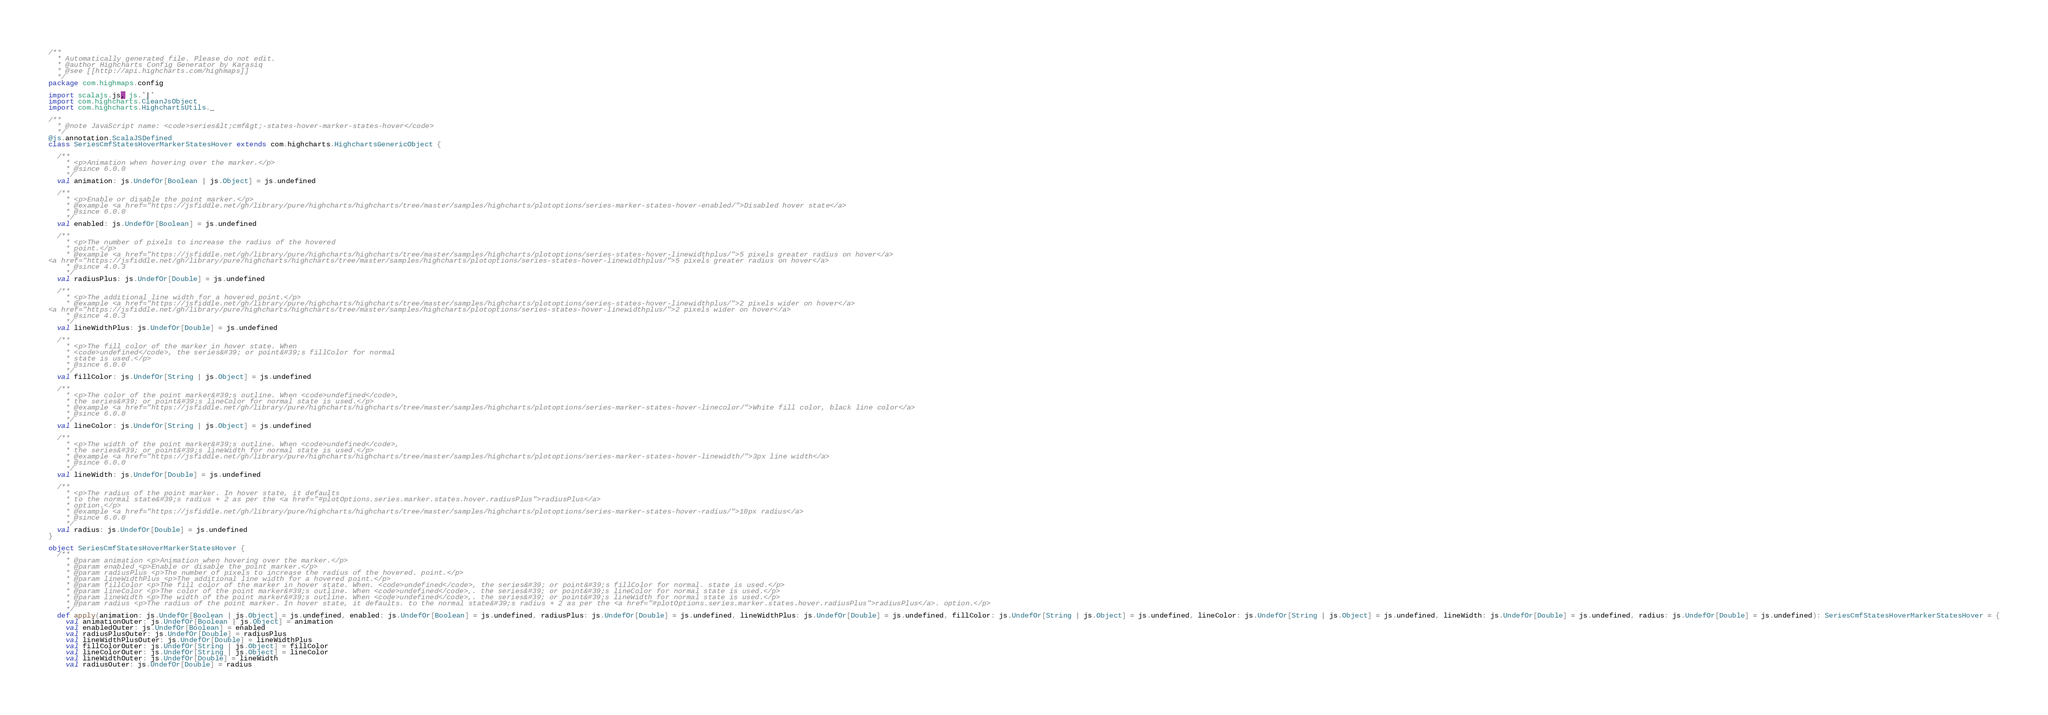<code> <loc_0><loc_0><loc_500><loc_500><_Scala_>/**
  * Automatically generated file. Please do not edit.
  * @author Highcharts Config Generator by Karasiq
  * @see [[http://api.highcharts.com/highmaps]]
  */
package com.highmaps.config

import scalajs.js, js.`|`
import com.highcharts.CleanJsObject
import com.highcharts.HighchartsUtils._

/**
  * @note JavaScript name: <code>series&lt;cmf&gt;-states-hover-marker-states-hover</code>
  */
@js.annotation.ScalaJSDefined
class SeriesCmfStatesHoverMarkerStatesHover extends com.highcharts.HighchartsGenericObject {

  /**
    * <p>Animation when hovering over the marker.</p>
    * @since 6.0.0
    */
  val animation: js.UndefOr[Boolean | js.Object] = js.undefined

  /**
    * <p>Enable or disable the point marker.</p>
    * @example <a href="https://jsfiddle.net/gh/library/pure/highcharts/highcharts/tree/master/samples/highcharts/plotoptions/series-marker-states-hover-enabled/">Disabled hover state</a>
    * @since 6.0.0
    */
  val enabled: js.UndefOr[Boolean] = js.undefined

  /**
    * <p>The number of pixels to increase the radius of the hovered
    * point.</p>
    * @example <a href="https://jsfiddle.net/gh/library/pure/highcharts/highcharts/tree/master/samples/highcharts/plotoptions/series-states-hover-linewidthplus/">5 pixels greater radius on hover</a>
<a href="https://jsfiddle.net/gh/library/pure/highcharts/highcharts/tree/master/samples/highcharts/plotoptions/series-states-hover-linewidthplus/">5 pixels greater radius on hover</a>
    * @since 4.0.3
    */
  val radiusPlus: js.UndefOr[Double] = js.undefined

  /**
    * <p>The additional line width for a hovered point.</p>
    * @example <a href="https://jsfiddle.net/gh/library/pure/highcharts/highcharts/tree/master/samples/highcharts/plotoptions/series-states-hover-linewidthplus/">2 pixels wider on hover</a>
<a href="https://jsfiddle.net/gh/library/pure/highcharts/highcharts/tree/master/samples/highcharts/plotoptions/series-states-hover-linewidthplus/">2 pixels wider on hover</a>
    * @since 4.0.3
    */
  val lineWidthPlus: js.UndefOr[Double] = js.undefined

  /**
    * <p>The fill color of the marker in hover state. When
    * <code>undefined</code>, the series&#39; or point&#39;s fillColor for normal
    * state is used.</p>
    * @since 6.0.0
    */
  val fillColor: js.UndefOr[String | js.Object] = js.undefined

  /**
    * <p>The color of the point marker&#39;s outline. When <code>undefined</code>,
    * the series&#39; or point&#39;s lineColor for normal state is used.</p>
    * @example <a href="https://jsfiddle.net/gh/library/pure/highcharts/highcharts/tree/master/samples/highcharts/plotoptions/series-marker-states-hover-linecolor/">White fill color, black line color</a>
    * @since 6.0.0
    */
  val lineColor: js.UndefOr[String | js.Object] = js.undefined

  /**
    * <p>The width of the point marker&#39;s outline. When <code>undefined</code>,
    * the series&#39; or point&#39;s lineWidth for normal state is used.</p>
    * @example <a href="https://jsfiddle.net/gh/library/pure/highcharts/highcharts/tree/master/samples/highcharts/plotoptions/series-marker-states-hover-linewidth/">3px line width</a>
    * @since 6.0.0
    */
  val lineWidth: js.UndefOr[Double] = js.undefined

  /**
    * <p>The radius of the point marker. In hover state, it defaults
    * to the normal state&#39;s radius + 2 as per the <a href="#plotOptions.series.marker.states.hover.radiusPlus">radiusPlus</a>
    * option.</p>
    * @example <a href="https://jsfiddle.net/gh/library/pure/highcharts/highcharts/tree/master/samples/highcharts/plotoptions/series-marker-states-hover-radius/">10px radius</a>
    * @since 6.0.0
    */
  val radius: js.UndefOr[Double] = js.undefined
}

object SeriesCmfStatesHoverMarkerStatesHover {
  /**
    * @param animation <p>Animation when hovering over the marker.</p>
    * @param enabled <p>Enable or disable the point marker.</p>
    * @param radiusPlus <p>The number of pixels to increase the radius of the hovered. point.</p>
    * @param lineWidthPlus <p>The additional line width for a hovered point.</p>
    * @param fillColor <p>The fill color of the marker in hover state. When. <code>undefined</code>, the series&#39; or point&#39;s fillColor for normal. state is used.</p>
    * @param lineColor <p>The color of the point marker&#39;s outline. When <code>undefined</code>,. the series&#39; or point&#39;s lineColor for normal state is used.</p>
    * @param lineWidth <p>The width of the point marker&#39;s outline. When <code>undefined</code>,. the series&#39; or point&#39;s lineWidth for normal state is used.</p>
    * @param radius <p>The radius of the point marker. In hover state, it defaults. to the normal state&#39;s radius + 2 as per the <a href="#plotOptions.series.marker.states.hover.radiusPlus">radiusPlus</a>. option.</p>
    */
  def apply(animation: js.UndefOr[Boolean | js.Object] = js.undefined, enabled: js.UndefOr[Boolean] = js.undefined, radiusPlus: js.UndefOr[Double] = js.undefined, lineWidthPlus: js.UndefOr[Double] = js.undefined, fillColor: js.UndefOr[String | js.Object] = js.undefined, lineColor: js.UndefOr[String | js.Object] = js.undefined, lineWidth: js.UndefOr[Double] = js.undefined, radius: js.UndefOr[Double] = js.undefined): SeriesCmfStatesHoverMarkerStatesHover = {
    val animationOuter: js.UndefOr[Boolean | js.Object] = animation
    val enabledOuter: js.UndefOr[Boolean] = enabled
    val radiusPlusOuter: js.UndefOr[Double] = radiusPlus
    val lineWidthPlusOuter: js.UndefOr[Double] = lineWidthPlus
    val fillColorOuter: js.UndefOr[String | js.Object] = fillColor
    val lineColorOuter: js.UndefOr[String | js.Object] = lineColor
    val lineWidthOuter: js.UndefOr[Double] = lineWidth
    val radiusOuter: js.UndefOr[Double] = radius</code> 